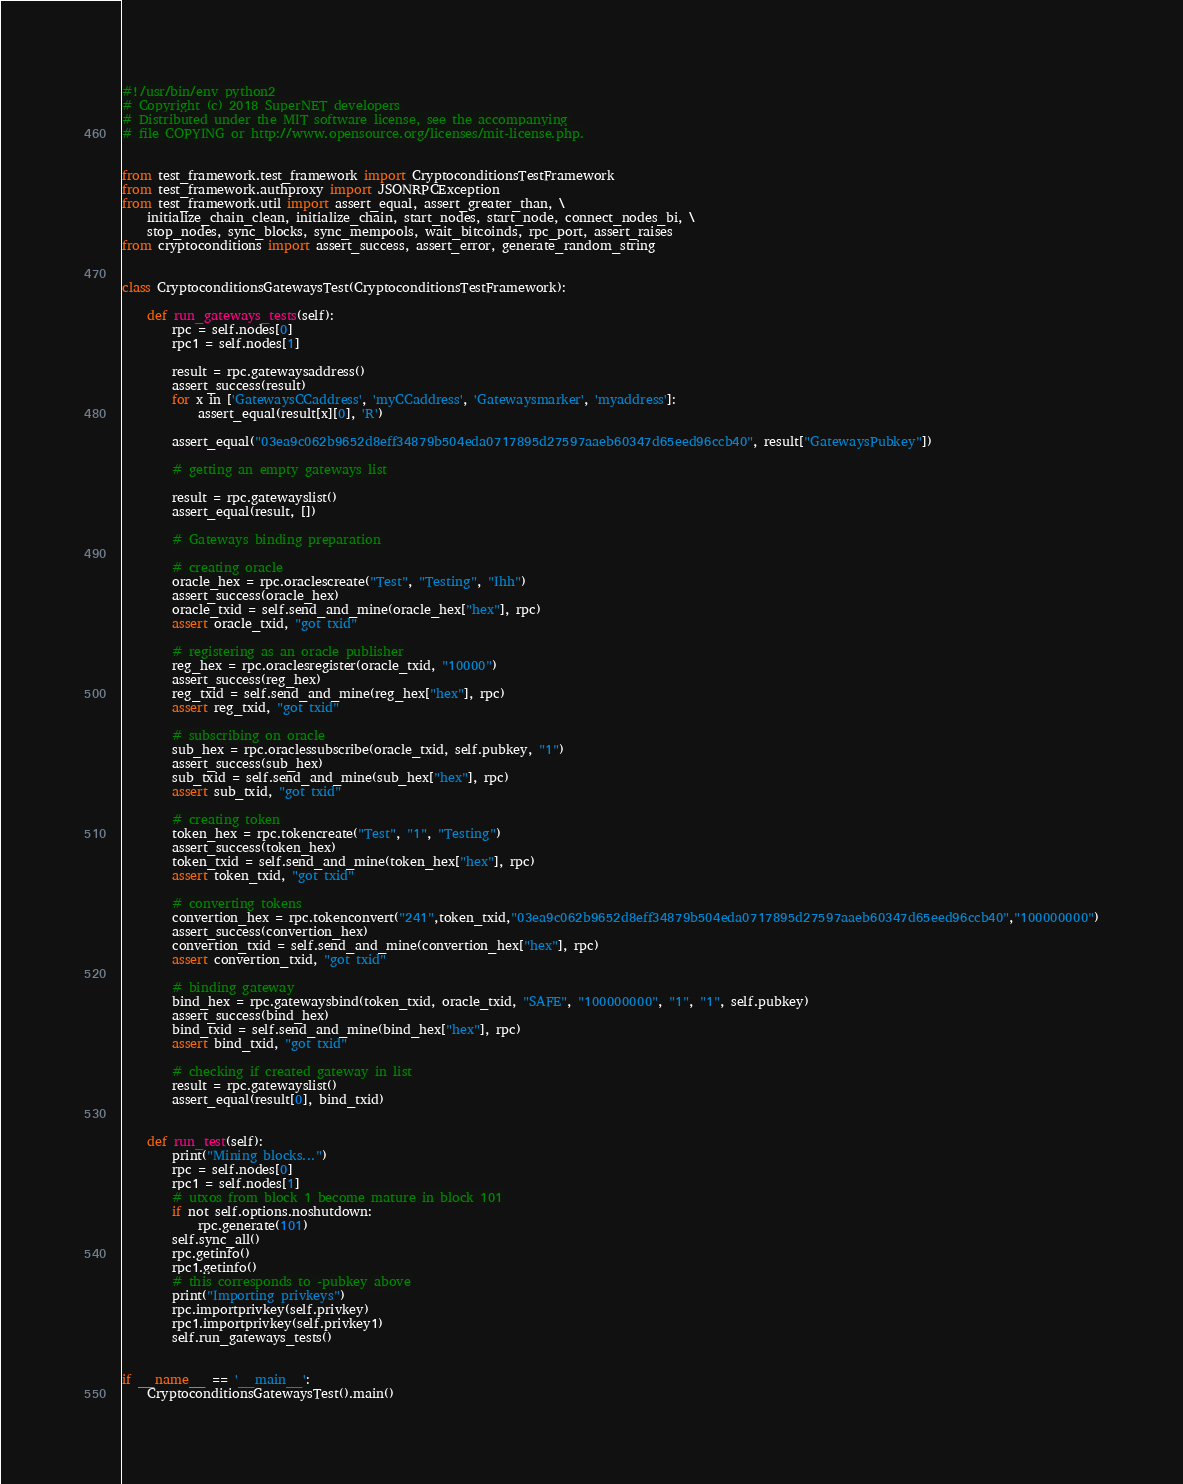Convert code to text. <code><loc_0><loc_0><loc_500><loc_500><_Python_>#!/usr/bin/env python2
# Copyright (c) 2018 SuperNET developers
# Distributed under the MIT software license, see the accompanying
# file COPYING or http://www.opensource.org/licenses/mit-license.php.


from test_framework.test_framework import CryptoconditionsTestFramework
from test_framework.authproxy import JSONRPCException
from test_framework.util import assert_equal, assert_greater_than, \
    initialize_chain_clean, initialize_chain, start_nodes, start_node, connect_nodes_bi, \
    stop_nodes, sync_blocks, sync_mempools, wait_bitcoinds, rpc_port, assert_raises
from cryptoconditions import assert_success, assert_error, generate_random_string


class CryptoconditionsGatewaysTest(CryptoconditionsTestFramework):

    def run_gateways_tests(self):
        rpc = self.nodes[0]
        rpc1 = self.nodes[1]

        result = rpc.gatewaysaddress()
        assert_success(result)
        for x in ['GatewaysCCaddress', 'myCCaddress', 'Gatewaysmarker', 'myaddress']:
            assert_equal(result[x][0], 'R')

        assert_equal("03ea9c062b9652d8eff34879b504eda0717895d27597aaeb60347d65eed96ccb40", result["GatewaysPubkey"])

        # getting an empty gateways list

        result = rpc.gatewayslist()
        assert_equal(result, [])

        # Gateways binding preparation

        # creating oracle
        oracle_hex = rpc.oraclescreate("Test", "Testing", "Ihh")
        assert_success(oracle_hex)
        oracle_txid = self.send_and_mine(oracle_hex["hex"], rpc)
        assert oracle_txid, "got txid"

        # registering as an oracle publisher
        reg_hex = rpc.oraclesregister(oracle_txid, "10000")
        assert_success(reg_hex)
        reg_txid = self.send_and_mine(reg_hex["hex"], rpc)
        assert reg_txid, "got txid"

        # subscribing on oracle
        sub_hex = rpc.oraclessubscribe(oracle_txid, self.pubkey, "1")
        assert_success(sub_hex)
        sub_txid = self.send_and_mine(sub_hex["hex"], rpc)
        assert sub_txid, "got txid"

        # creating token
        token_hex = rpc.tokencreate("Test", "1", "Testing")
        assert_success(token_hex)
        token_txid = self.send_and_mine(token_hex["hex"], rpc)
        assert token_txid, "got txid"

        # converting tokens
        convertion_hex = rpc.tokenconvert("241",token_txid,"03ea9c062b9652d8eff34879b504eda0717895d27597aaeb60347d65eed96ccb40","100000000")
        assert_success(convertion_hex)
        convertion_txid = self.send_and_mine(convertion_hex["hex"], rpc)
        assert convertion_txid, "got txid"

        # binding gateway
        bind_hex = rpc.gatewaysbind(token_txid, oracle_txid, "SAFE", "100000000", "1", "1", self.pubkey)
        assert_success(bind_hex)
        bind_txid = self.send_and_mine(bind_hex["hex"], rpc)
        assert bind_txid, "got txid"

        # checking if created gateway in list
        result = rpc.gatewayslist()
        assert_equal(result[0], bind_txid)


    def run_test(self):
        print("Mining blocks...")
        rpc = self.nodes[0]
        rpc1 = self.nodes[1]
        # utxos from block 1 become mature in block 101
        if not self.options.noshutdown:
            rpc.generate(101)
        self.sync_all()
        rpc.getinfo()
        rpc1.getinfo()
        # this corresponds to -pubkey above
        print("Importing privkeys")
        rpc.importprivkey(self.privkey)
        rpc1.importprivkey(self.privkey1)
        self.run_gateways_tests()


if __name__ == '__main__':
    CryptoconditionsGatewaysTest().main()
</code> 